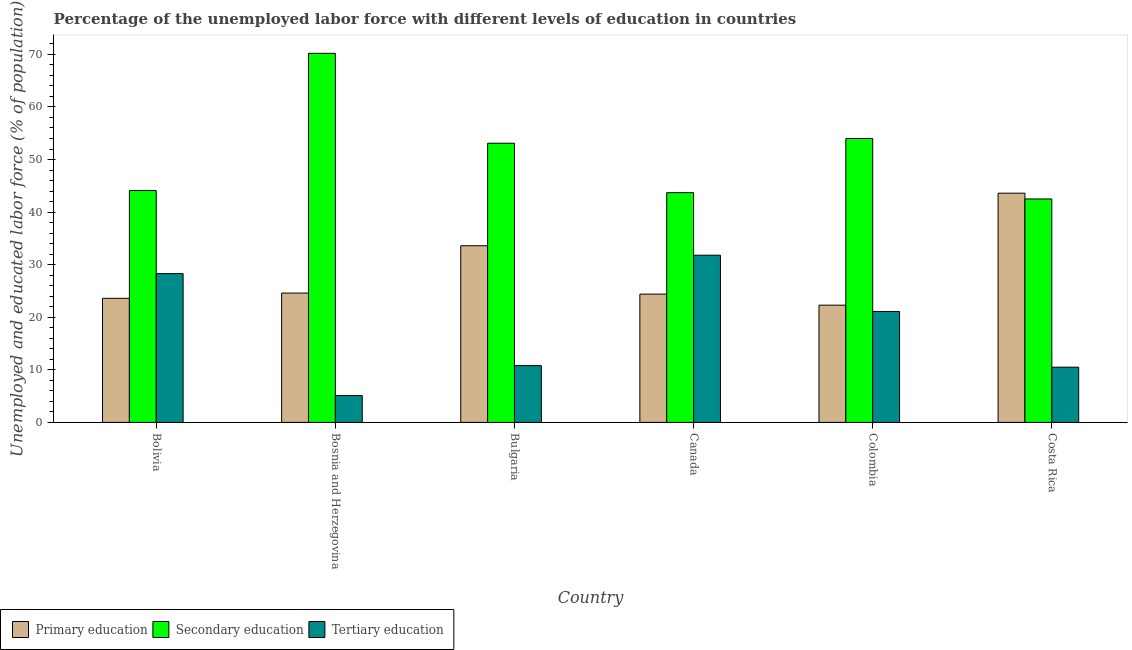Are the number of bars on each tick of the X-axis equal?
Make the answer very short. Yes. How many bars are there on the 1st tick from the left?
Keep it short and to the point. 3. How many bars are there on the 5th tick from the right?
Provide a short and direct response. 3. What is the percentage of labor force who received primary education in Bosnia and Herzegovina?
Your answer should be compact. 24.6. Across all countries, what is the maximum percentage of labor force who received primary education?
Keep it short and to the point. 43.6. Across all countries, what is the minimum percentage of labor force who received tertiary education?
Offer a terse response. 5.1. What is the total percentage of labor force who received secondary education in the graph?
Your answer should be compact. 307.6. What is the difference between the percentage of labor force who received tertiary education in Bolivia and that in Bosnia and Herzegovina?
Keep it short and to the point. 23.2. What is the difference between the percentage of labor force who received primary education in Bulgaria and the percentage of labor force who received secondary education in Canada?
Give a very brief answer. -10.1. What is the average percentage of labor force who received primary education per country?
Ensure brevity in your answer.  28.68. What is the difference between the percentage of labor force who received tertiary education and percentage of labor force who received secondary education in Colombia?
Make the answer very short. -32.9. What is the ratio of the percentage of labor force who received tertiary education in Bosnia and Herzegovina to that in Colombia?
Offer a very short reply. 0.24. What is the difference between the highest and the lowest percentage of labor force who received primary education?
Provide a succinct answer. 21.3. In how many countries, is the percentage of labor force who received tertiary education greater than the average percentage of labor force who received tertiary education taken over all countries?
Your answer should be compact. 3. What does the 1st bar from the right in Bulgaria represents?
Provide a succinct answer. Tertiary education. Are all the bars in the graph horizontal?
Offer a very short reply. No. How many countries are there in the graph?
Make the answer very short. 6. Are the values on the major ticks of Y-axis written in scientific E-notation?
Keep it short and to the point. No. Does the graph contain any zero values?
Keep it short and to the point. No. Where does the legend appear in the graph?
Give a very brief answer. Bottom left. How are the legend labels stacked?
Provide a short and direct response. Horizontal. What is the title of the graph?
Your answer should be very brief. Percentage of the unemployed labor force with different levels of education in countries. What is the label or title of the Y-axis?
Provide a short and direct response. Unemployed and educated labor force (% of population). What is the Unemployed and educated labor force (% of population) in Primary education in Bolivia?
Your answer should be compact. 23.6. What is the Unemployed and educated labor force (% of population) of Secondary education in Bolivia?
Offer a terse response. 44.1. What is the Unemployed and educated labor force (% of population) of Tertiary education in Bolivia?
Provide a succinct answer. 28.3. What is the Unemployed and educated labor force (% of population) in Primary education in Bosnia and Herzegovina?
Provide a short and direct response. 24.6. What is the Unemployed and educated labor force (% of population) in Secondary education in Bosnia and Herzegovina?
Your answer should be very brief. 70.2. What is the Unemployed and educated labor force (% of population) of Tertiary education in Bosnia and Herzegovina?
Ensure brevity in your answer.  5.1. What is the Unemployed and educated labor force (% of population) of Primary education in Bulgaria?
Give a very brief answer. 33.6. What is the Unemployed and educated labor force (% of population) in Secondary education in Bulgaria?
Give a very brief answer. 53.1. What is the Unemployed and educated labor force (% of population) in Tertiary education in Bulgaria?
Your answer should be very brief. 10.8. What is the Unemployed and educated labor force (% of population) in Primary education in Canada?
Keep it short and to the point. 24.4. What is the Unemployed and educated labor force (% of population) of Secondary education in Canada?
Give a very brief answer. 43.7. What is the Unemployed and educated labor force (% of population) in Tertiary education in Canada?
Offer a terse response. 31.8. What is the Unemployed and educated labor force (% of population) of Primary education in Colombia?
Offer a very short reply. 22.3. What is the Unemployed and educated labor force (% of population) of Tertiary education in Colombia?
Provide a succinct answer. 21.1. What is the Unemployed and educated labor force (% of population) of Primary education in Costa Rica?
Your response must be concise. 43.6. What is the Unemployed and educated labor force (% of population) in Secondary education in Costa Rica?
Make the answer very short. 42.5. What is the Unemployed and educated labor force (% of population) of Tertiary education in Costa Rica?
Give a very brief answer. 10.5. Across all countries, what is the maximum Unemployed and educated labor force (% of population) in Primary education?
Provide a succinct answer. 43.6. Across all countries, what is the maximum Unemployed and educated labor force (% of population) of Secondary education?
Provide a succinct answer. 70.2. Across all countries, what is the maximum Unemployed and educated labor force (% of population) in Tertiary education?
Your answer should be very brief. 31.8. Across all countries, what is the minimum Unemployed and educated labor force (% of population) in Primary education?
Offer a very short reply. 22.3. Across all countries, what is the minimum Unemployed and educated labor force (% of population) in Secondary education?
Keep it short and to the point. 42.5. Across all countries, what is the minimum Unemployed and educated labor force (% of population) in Tertiary education?
Keep it short and to the point. 5.1. What is the total Unemployed and educated labor force (% of population) in Primary education in the graph?
Your answer should be compact. 172.1. What is the total Unemployed and educated labor force (% of population) of Secondary education in the graph?
Offer a terse response. 307.6. What is the total Unemployed and educated labor force (% of population) of Tertiary education in the graph?
Provide a succinct answer. 107.6. What is the difference between the Unemployed and educated labor force (% of population) of Secondary education in Bolivia and that in Bosnia and Herzegovina?
Provide a succinct answer. -26.1. What is the difference between the Unemployed and educated labor force (% of population) in Tertiary education in Bolivia and that in Bosnia and Herzegovina?
Offer a terse response. 23.2. What is the difference between the Unemployed and educated labor force (% of population) in Primary education in Bolivia and that in Canada?
Provide a succinct answer. -0.8. What is the difference between the Unemployed and educated labor force (% of population) in Secondary education in Bolivia and that in Canada?
Provide a succinct answer. 0.4. What is the difference between the Unemployed and educated labor force (% of population) in Tertiary education in Bolivia and that in Canada?
Ensure brevity in your answer.  -3.5. What is the difference between the Unemployed and educated labor force (% of population) of Primary education in Bolivia and that in Colombia?
Ensure brevity in your answer.  1.3. What is the difference between the Unemployed and educated labor force (% of population) of Secondary education in Bolivia and that in Colombia?
Your answer should be compact. -9.9. What is the difference between the Unemployed and educated labor force (% of population) of Tertiary education in Bolivia and that in Colombia?
Provide a short and direct response. 7.2. What is the difference between the Unemployed and educated labor force (% of population) in Secondary education in Bolivia and that in Costa Rica?
Give a very brief answer. 1.6. What is the difference between the Unemployed and educated labor force (% of population) of Tertiary education in Bolivia and that in Costa Rica?
Give a very brief answer. 17.8. What is the difference between the Unemployed and educated labor force (% of population) in Primary education in Bosnia and Herzegovina and that in Bulgaria?
Offer a very short reply. -9. What is the difference between the Unemployed and educated labor force (% of population) in Secondary education in Bosnia and Herzegovina and that in Bulgaria?
Give a very brief answer. 17.1. What is the difference between the Unemployed and educated labor force (% of population) of Primary education in Bosnia and Herzegovina and that in Canada?
Give a very brief answer. 0.2. What is the difference between the Unemployed and educated labor force (% of population) in Secondary education in Bosnia and Herzegovina and that in Canada?
Offer a very short reply. 26.5. What is the difference between the Unemployed and educated labor force (% of population) of Tertiary education in Bosnia and Herzegovina and that in Canada?
Your response must be concise. -26.7. What is the difference between the Unemployed and educated labor force (% of population) in Primary education in Bosnia and Herzegovina and that in Colombia?
Your answer should be compact. 2.3. What is the difference between the Unemployed and educated labor force (% of population) in Secondary education in Bosnia and Herzegovina and that in Colombia?
Give a very brief answer. 16.2. What is the difference between the Unemployed and educated labor force (% of population) of Tertiary education in Bosnia and Herzegovina and that in Colombia?
Your response must be concise. -16. What is the difference between the Unemployed and educated labor force (% of population) of Primary education in Bosnia and Herzegovina and that in Costa Rica?
Your response must be concise. -19. What is the difference between the Unemployed and educated labor force (% of population) of Secondary education in Bosnia and Herzegovina and that in Costa Rica?
Ensure brevity in your answer.  27.7. What is the difference between the Unemployed and educated labor force (% of population) in Tertiary education in Bosnia and Herzegovina and that in Costa Rica?
Ensure brevity in your answer.  -5.4. What is the difference between the Unemployed and educated labor force (% of population) of Tertiary education in Bulgaria and that in Canada?
Provide a succinct answer. -21. What is the difference between the Unemployed and educated labor force (% of population) in Primary education in Bulgaria and that in Colombia?
Make the answer very short. 11.3. What is the difference between the Unemployed and educated labor force (% of population) of Tertiary education in Bulgaria and that in Colombia?
Your answer should be compact. -10.3. What is the difference between the Unemployed and educated labor force (% of population) of Primary education in Bulgaria and that in Costa Rica?
Your answer should be very brief. -10. What is the difference between the Unemployed and educated labor force (% of population) in Secondary education in Bulgaria and that in Costa Rica?
Ensure brevity in your answer.  10.6. What is the difference between the Unemployed and educated labor force (% of population) of Tertiary education in Bulgaria and that in Costa Rica?
Keep it short and to the point. 0.3. What is the difference between the Unemployed and educated labor force (% of population) of Primary education in Canada and that in Colombia?
Ensure brevity in your answer.  2.1. What is the difference between the Unemployed and educated labor force (% of population) of Secondary education in Canada and that in Colombia?
Give a very brief answer. -10.3. What is the difference between the Unemployed and educated labor force (% of population) of Primary education in Canada and that in Costa Rica?
Provide a succinct answer. -19.2. What is the difference between the Unemployed and educated labor force (% of population) in Secondary education in Canada and that in Costa Rica?
Provide a succinct answer. 1.2. What is the difference between the Unemployed and educated labor force (% of population) of Tertiary education in Canada and that in Costa Rica?
Your response must be concise. 21.3. What is the difference between the Unemployed and educated labor force (% of population) in Primary education in Colombia and that in Costa Rica?
Ensure brevity in your answer.  -21.3. What is the difference between the Unemployed and educated labor force (% of population) of Secondary education in Colombia and that in Costa Rica?
Your answer should be very brief. 11.5. What is the difference between the Unemployed and educated labor force (% of population) in Primary education in Bolivia and the Unemployed and educated labor force (% of population) in Secondary education in Bosnia and Herzegovina?
Ensure brevity in your answer.  -46.6. What is the difference between the Unemployed and educated labor force (% of population) of Primary education in Bolivia and the Unemployed and educated labor force (% of population) of Tertiary education in Bosnia and Herzegovina?
Provide a succinct answer. 18.5. What is the difference between the Unemployed and educated labor force (% of population) of Secondary education in Bolivia and the Unemployed and educated labor force (% of population) of Tertiary education in Bosnia and Herzegovina?
Provide a short and direct response. 39. What is the difference between the Unemployed and educated labor force (% of population) of Primary education in Bolivia and the Unemployed and educated labor force (% of population) of Secondary education in Bulgaria?
Keep it short and to the point. -29.5. What is the difference between the Unemployed and educated labor force (% of population) in Primary education in Bolivia and the Unemployed and educated labor force (% of population) in Tertiary education in Bulgaria?
Provide a succinct answer. 12.8. What is the difference between the Unemployed and educated labor force (% of population) of Secondary education in Bolivia and the Unemployed and educated labor force (% of population) of Tertiary education in Bulgaria?
Keep it short and to the point. 33.3. What is the difference between the Unemployed and educated labor force (% of population) of Primary education in Bolivia and the Unemployed and educated labor force (% of population) of Secondary education in Canada?
Keep it short and to the point. -20.1. What is the difference between the Unemployed and educated labor force (% of population) in Secondary education in Bolivia and the Unemployed and educated labor force (% of population) in Tertiary education in Canada?
Ensure brevity in your answer.  12.3. What is the difference between the Unemployed and educated labor force (% of population) of Primary education in Bolivia and the Unemployed and educated labor force (% of population) of Secondary education in Colombia?
Make the answer very short. -30.4. What is the difference between the Unemployed and educated labor force (% of population) of Primary education in Bolivia and the Unemployed and educated labor force (% of population) of Tertiary education in Colombia?
Your answer should be very brief. 2.5. What is the difference between the Unemployed and educated labor force (% of population) of Secondary education in Bolivia and the Unemployed and educated labor force (% of population) of Tertiary education in Colombia?
Your answer should be very brief. 23. What is the difference between the Unemployed and educated labor force (% of population) of Primary education in Bolivia and the Unemployed and educated labor force (% of population) of Secondary education in Costa Rica?
Offer a terse response. -18.9. What is the difference between the Unemployed and educated labor force (% of population) in Secondary education in Bolivia and the Unemployed and educated labor force (% of population) in Tertiary education in Costa Rica?
Offer a very short reply. 33.6. What is the difference between the Unemployed and educated labor force (% of population) of Primary education in Bosnia and Herzegovina and the Unemployed and educated labor force (% of population) of Secondary education in Bulgaria?
Offer a very short reply. -28.5. What is the difference between the Unemployed and educated labor force (% of population) of Primary education in Bosnia and Herzegovina and the Unemployed and educated labor force (% of population) of Tertiary education in Bulgaria?
Keep it short and to the point. 13.8. What is the difference between the Unemployed and educated labor force (% of population) in Secondary education in Bosnia and Herzegovina and the Unemployed and educated labor force (% of population) in Tertiary education in Bulgaria?
Ensure brevity in your answer.  59.4. What is the difference between the Unemployed and educated labor force (% of population) in Primary education in Bosnia and Herzegovina and the Unemployed and educated labor force (% of population) in Secondary education in Canada?
Provide a short and direct response. -19.1. What is the difference between the Unemployed and educated labor force (% of population) in Primary education in Bosnia and Herzegovina and the Unemployed and educated labor force (% of population) in Tertiary education in Canada?
Provide a succinct answer. -7.2. What is the difference between the Unemployed and educated labor force (% of population) of Secondary education in Bosnia and Herzegovina and the Unemployed and educated labor force (% of population) of Tertiary education in Canada?
Offer a terse response. 38.4. What is the difference between the Unemployed and educated labor force (% of population) in Primary education in Bosnia and Herzegovina and the Unemployed and educated labor force (% of population) in Secondary education in Colombia?
Your answer should be compact. -29.4. What is the difference between the Unemployed and educated labor force (% of population) in Secondary education in Bosnia and Herzegovina and the Unemployed and educated labor force (% of population) in Tertiary education in Colombia?
Your answer should be compact. 49.1. What is the difference between the Unemployed and educated labor force (% of population) in Primary education in Bosnia and Herzegovina and the Unemployed and educated labor force (% of population) in Secondary education in Costa Rica?
Ensure brevity in your answer.  -17.9. What is the difference between the Unemployed and educated labor force (% of population) in Secondary education in Bosnia and Herzegovina and the Unemployed and educated labor force (% of population) in Tertiary education in Costa Rica?
Your answer should be very brief. 59.7. What is the difference between the Unemployed and educated labor force (% of population) in Primary education in Bulgaria and the Unemployed and educated labor force (% of population) in Secondary education in Canada?
Ensure brevity in your answer.  -10.1. What is the difference between the Unemployed and educated labor force (% of population) of Primary education in Bulgaria and the Unemployed and educated labor force (% of population) of Tertiary education in Canada?
Give a very brief answer. 1.8. What is the difference between the Unemployed and educated labor force (% of population) in Secondary education in Bulgaria and the Unemployed and educated labor force (% of population) in Tertiary education in Canada?
Keep it short and to the point. 21.3. What is the difference between the Unemployed and educated labor force (% of population) of Primary education in Bulgaria and the Unemployed and educated labor force (% of population) of Secondary education in Colombia?
Give a very brief answer. -20.4. What is the difference between the Unemployed and educated labor force (% of population) of Secondary education in Bulgaria and the Unemployed and educated labor force (% of population) of Tertiary education in Colombia?
Ensure brevity in your answer.  32. What is the difference between the Unemployed and educated labor force (% of population) in Primary education in Bulgaria and the Unemployed and educated labor force (% of population) in Tertiary education in Costa Rica?
Your response must be concise. 23.1. What is the difference between the Unemployed and educated labor force (% of population) of Secondary education in Bulgaria and the Unemployed and educated labor force (% of population) of Tertiary education in Costa Rica?
Keep it short and to the point. 42.6. What is the difference between the Unemployed and educated labor force (% of population) of Primary education in Canada and the Unemployed and educated labor force (% of population) of Secondary education in Colombia?
Your answer should be very brief. -29.6. What is the difference between the Unemployed and educated labor force (% of population) in Primary education in Canada and the Unemployed and educated labor force (% of population) in Tertiary education in Colombia?
Provide a short and direct response. 3.3. What is the difference between the Unemployed and educated labor force (% of population) of Secondary education in Canada and the Unemployed and educated labor force (% of population) of Tertiary education in Colombia?
Keep it short and to the point. 22.6. What is the difference between the Unemployed and educated labor force (% of population) in Primary education in Canada and the Unemployed and educated labor force (% of population) in Secondary education in Costa Rica?
Your response must be concise. -18.1. What is the difference between the Unemployed and educated labor force (% of population) of Primary education in Canada and the Unemployed and educated labor force (% of population) of Tertiary education in Costa Rica?
Your answer should be compact. 13.9. What is the difference between the Unemployed and educated labor force (% of population) of Secondary education in Canada and the Unemployed and educated labor force (% of population) of Tertiary education in Costa Rica?
Your response must be concise. 33.2. What is the difference between the Unemployed and educated labor force (% of population) of Primary education in Colombia and the Unemployed and educated labor force (% of population) of Secondary education in Costa Rica?
Your answer should be compact. -20.2. What is the difference between the Unemployed and educated labor force (% of population) of Secondary education in Colombia and the Unemployed and educated labor force (% of population) of Tertiary education in Costa Rica?
Your answer should be compact. 43.5. What is the average Unemployed and educated labor force (% of population) in Primary education per country?
Your answer should be very brief. 28.68. What is the average Unemployed and educated labor force (% of population) in Secondary education per country?
Offer a terse response. 51.27. What is the average Unemployed and educated labor force (% of population) in Tertiary education per country?
Offer a terse response. 17.93. What is the difference between the Unemployed and educated labor force (% of population) of Primary education and Unemployed and educated labor force (% of population) of Secondary education in Bolivia?
Provide a succinct answer. -20.5. What is the difference between the Unemployed and educated labor force (% of population) of Secondary education and Unemployed and educated labor force (% of population) of Tertiary education in Bolivia?
Your answer should be very brief. 15.8. What is the difference between the Unemployed and educated labor force (% of population) in Primary education and Unemployed and educated labor force (% of population) in Secondary education in Bosnia and Herzegovina?
Your answer should be compact. -45.6. What is the difference between the Unemployed and educated labor force (% of population) of Primary education and Unemployed and educated labor force (% of population) of Tertiary education in Bosnia and Herzegovina?
Provide a succinct answer. 19.5. What is the difference between the Unemployed and educated labor force (% of population) in Secondary education and Unemployed and educated labor force (% of population) in Tertiary education in Bosnia and Herzegovina?
Your answer should be compact. 65.1. What is the difference between the Unemployed and educated labor force (% of population) of Primary education and Unemployed and educated labor force (% of population) of Secondary education in Bulgaria?
Your answer should be compact. -19.5. What is the difference between the Unemployed and educated labor force (% of population) of Primary education and Unemployed and educated labor force (% of population) of Tertiary education in Bulgaria?
Provide a short and direct response. 22.8. What is the difference between the Unemployed and educated labor force (% of population) of Secondary education and Unemployed and educated labor force (% of population) of Tertiary education in Bulgaria?
Ensure brevity in your answer.  42.3. What is the difference between the Unemployed and educated labor force (% of population) in Primary education and Unemployed and educated labor force (% of population) in Secondary education in Canada?
Give a very brief answer. -19.3. What is the difference between the Unemployed and educated labor force (% of population) of Primary education and Unemployed and educated labor force (% of population) of Tertiary education in Canada?
Give a very brief answer. -7.4. What is the difference between the Unemployed and educated labor force (% of population) in Secondary education and Unemployed and educated labor force (% of population) in Tertiary education in Canada?
Provide a succinct answer. 11.9. What is the difference between the Unemployed and educated labor force (% of population) in Primary education and Unemployed and educated labor force (% of population) in Secondary education in Colombia?
Your answer should be compact. -31.7. What is the difference between the Unemployed and educated labor force (% of population) of Secondary education and Unemployed and educated labor force (% of population) of Tertiary education in Colombia?
Provide a succinct answer. 32.9. What is the difference between the Unemployed and educated labor force (% of population) in Primary education and Unemployed and educated labor force (% of population) in Tertiary education in Costa Rica?
Provide a succinct answer. 33.1. What is the difference between the Unemployed and educated labor force (% of population) in Secondary education and Unemployed and educated labor force (% of population) in Tertiary education in Costa Rica?
Keep it short and to the point. 32. What is the ratio of the Unemployed and educated labor force (% of population) in Primary education in Bolivia to that in Bosnia and Herzegovina?
Keep it short and to the point. 0.96. What is the ratio of the Unemployed and educated labor force (% of population) in Secondary education in Bolivia to that in Bosnia and Herzegovina?
Give a very brief answer. 0.63. What is the ratio of the Unemployed and educated labor force (% of population) in Tertiary education in Bolivia to that in Bosnia and Herzegovina?
Your response must be concise. 5.55. What is the ratio of the Unemployed and educated labor force (% of population) in Primary education in Bolivia to that in Bulgaria?
Keep it short and to the point. 0.7. What is the ratio of the Unemployed and educated labor force (% of population) of Secondary education in Bolivia to that in Bulgaria?
Offer a very short reply. 0.83. What is the ratio of the Unemployed and educated labor force (% of population) in Tertiary education in Bolivia to that in Bulgaria?
Ensure brevity in your answer.  2.62. What is the ratio of the Unemployed and educated labor force (% of population) of Primary education in Bolivia to that in Canada?
Give a very brief answer. 0.97. What is the ratio of the Unemployed and educated labor force (% of population) of Secondary education in Bolivia to that in Canada?
Your response must be concise. 1.01. What is the ratio of the Unemployed and educated labor force (% of population) in Tertiary education in Bolivia to that in Canada?
Ensure brevity in your answer.  0.89. What is the ratio of the Unemployed and educated labor force (% of population) in Primary education in Bolivia to that in Colombia?
Your response must be concise. 1.06. What is the ratio of the Unemployed and educated labor force (% of population) in Secondary education in Bolivia to that in Colombia?
Your answer should be very brief. 0.82. What is the ratio of the Unemployed and educated labor force (% of population) of Tertiary education in Bolivia to that in Colombia?
Ensure brevity in your answer.  1.34. What is the ratio of the Unemployed and educated labor force (% of population) of Primary education in Bolivia to that in Costa Rica?
Offer a terse response. 0.54. What is the ratio of the Unemployed and educated labor force (% of population) of Secondary education in Bolivia to that in Costa Rica?
Give a very brief answer. 1.04. What is the ratio of the Unemployed and educated labor force (% of population) in Tertiary education in Bolivia to that in Costa Rica?
Your response must be concise. 2.7. What is the ratio of the Unemployed and educated labor force (% of population) in Primary education in Bosnia and Herzegovina to that in Bulgaria?
Offer a terse response. 0.73. What is the ratio of the Unemployed and educated labor force (% of population) of Secondary education in Bosnia and Herzegovina to that in Bulgaria?
Your answer should be very brief. 1.32. What is the ratio of the Unemployed and educated labor force (% of population) in Tertiary education in Bosnia and Herzegovina to that in Bulgaria?
Offer a terse response. 0.47. What is the ratio of the Unemployed and educated labor force (% of population) of Primary education in Bosnia and Herzegovina to that in Canada?
Offer a terse response. 1.01. What is the ratio of the Unemployed and educated labor force (% of population) of Secondary education in Bosnia and Herzegovina to that in Canada?
Make the answer very short. 1.61. What is the ratio of the Unemployed and educated labor force (% of population) in Tertiary education in Bosnia and Herzegovina to that in Canada?
Provide a short and direct response. 0.16. What is the ratio of the Unemployed and educated labor force (% of population) in Primary education in Bosnia and Herzegovina to that in Colombia?
Make the answer very short. 1.1. What is the ratio of the Unemployed and educated labor force (% of population) of Tertiary education in Bosnia and Herzegovina to that in Colombia?
Your response must be concise. 0.24. What is the ratio of the Unemployed and educated labor force (% of population) of Primary education in Bosnia and Herzegovina to that in Costa Rica?
Your answer should be compact. 0.56. What is the ratio of the Unemployed and educated labor force (% of population) of Secondary education in Bosnia and Herzegovina to that in Costa Rica?
Keep it short and to the point. 1.65. What is the ratio of the Unemployed and educated labor force (% of population) in Tertiary education in Bosnia and Herzegovina to that in Costa Rica?
Your response must be concise. 0.49. What is the ratio of the Unemployed and educated labor force (% of population) in Primary education in Bulgaria to that in Canada?
Offer a terse response. 1.38. What is the ratio of the Unemployed and educated labor force (% of population) of Secondary education in Bulgaria to that in Canada?
Make the answer very short. 1.22. What is the ratio of the Unemployed and educated labor force (% of population) in Tertiary education in Bulgaria to that in Canada?
Ensure brevity in your answer.  0.34. What is the ratio of the Unemployed and educated labor force (% of population) of Primary education in Bulgaria to that in Colombia?
Offer a very short reply. 1.51. What is the ratio of the Unemployed and educated labor force (% of population) of Secondary education in Bulgaria to that in Colombia?
Keep it short and to the point. 0.98. What is the ratio of the Unemployed and educated labor force (% of population) of Tertiary education in Bulgaria to that in Colombia?
Ensure brevity in your answer.  0.51. What is the ratio of the Unemployed and educated labor force (% of population) of Primary education in Bulgaria to that in Costa Rica?
Give a very brief answer. 0.77. What is the ratio of the Unemployed and educated labor force (% of population) of Secondary education in Bulgaria to that in Costa Rica?
Your response must be concise. 1.25. What is the ratio of the Unemployed and educated labor force (% of population) in Tertiary education in Bulgaria to that in Costa Rica?
Offer a very short reply. 1.03. What is the ratio of the Unemployed and educated labor force (% of population) in Primary education in Canada to that in Colombia?
Make the answer very short. 1.09. What is the ratio of the Unemployed and educated labor force (% of population) in Secondary education in Canada to that in Colombia?
Your answer should be compact. 0.81. What is the ratio of the Unemployed and educated labor force (% of population) of Tertiary education in Canada to that in Colombia?
Offer a terse response. 1.51. What is the ratio of the Unemployed and educated labor force (% of population) in Primary education in Canada to that in Costa Rica?
Your answer should be compact. 0.56. What is the ratio of the Unemployed and educated labor force (% of population) in Secondary education in Canada to that in Costa Rica?
Keep it short and to the point. 1.03. What is the ratio of the Unemployed and educated labor force (% of population) of Tertiary education in Canada to that in Costa Rica?
Make the answer very short. 3.03. What is the ratio of the Unemployed and educated labor force (% of population) in Primary education in Colombia to that in Costa Rica?
Give a very brief answer. 0.51. What is the ratio of the Unemployed and educated labor force (% of population) in Secondary education in Colombia to that in Costa Rica?
Your response must be concise. 1.27. What is the ratio of the Unemployed and educated labor force (% of population) in Tertiary education in Colombia to that in Costa Rica?
Offer a very short reply. 2.01. What is the difference between the highest and the second highest Unemployed and educated labor force (% of population) in Primary education?
Offer a very short reply. 10. What is the difference between the highest and the second highest Unemployed and educated labor force (% of population) in Secondary education?
Your answer should be very brief. 16.2. What is the difference between the highest and the second highest Unemployed and educated labor force (% of population) in Tertiary education?
Ensure brevity in your answer.  3.5. What is the difference between the highest and the lowest Unemployed and educated labor force (% of population) in Primary education?
Your answer should be compact. 21.3. What is the difference between the highest and the lowest Unemployed and educated labor force (% of population) of Secondary education?
Give a very brief answer. 27.7. What is the difference between the highest and the lowest Unemployed and educated labor force (% of population) of Tertiary education?
Your answer should be very brief. 26.7. 